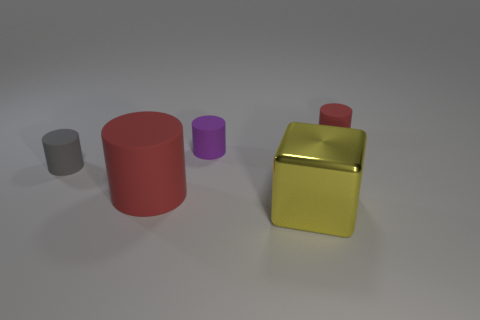Subtract 1 cylinders. How many cylinders are left? 3 Add 2 red rubber cylinders. How many objects exist? 7 Subtract all blocks. How many objects are left? 4 Add 3 large cylinders. How many large cylinders are left? 4 Add 1 tiny purple things. How many tiny purple things exist? 2 Subtract 0 brown spheres. How many objects are left? 5 Subtract all purple matte cylinders. Subtract all small red rubber cylinders. How many objects are left? 3 